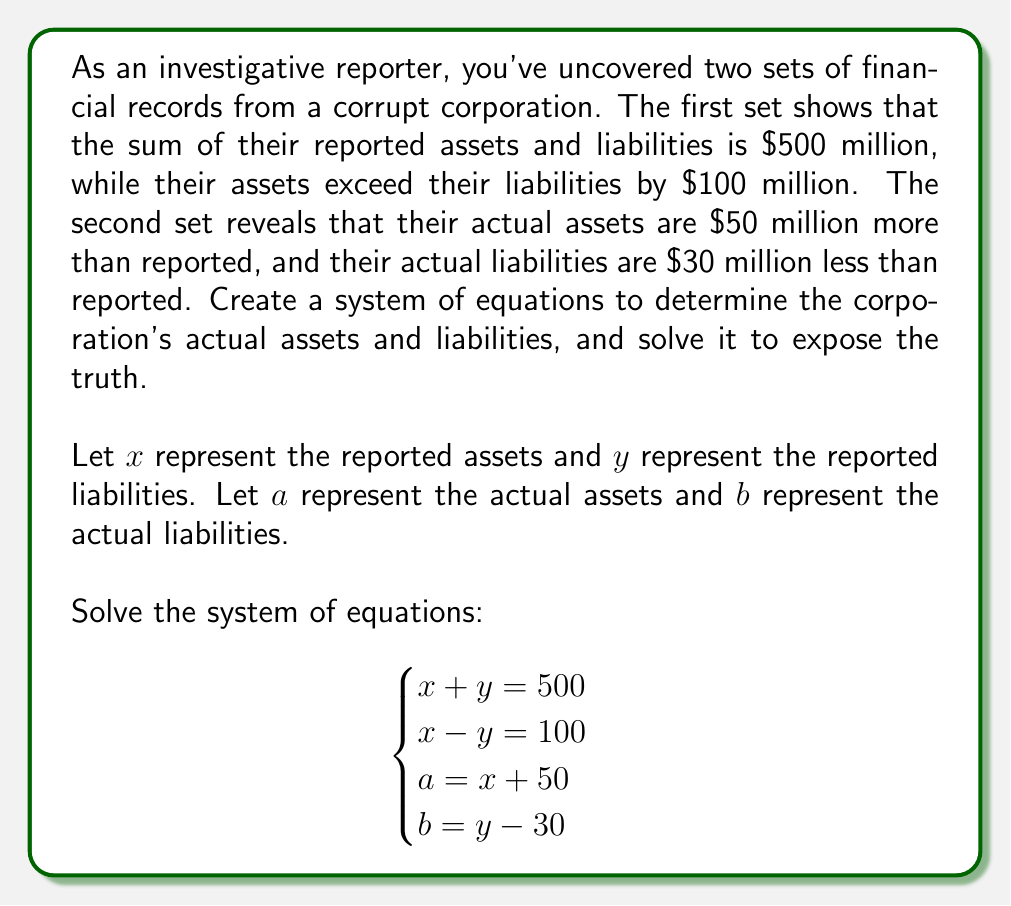Teach me how to tackle this problem. Let's solve this system of equations step by step:

1) From the first two equations, we can solve for $x$ and $y$:
   
   $$x + y = 500 \quad (1)$$
   $$x - y = 100 \quad (2)$$

   Adding (1) and (2):
   $$2x = 600$$
   $$x = 300$$

   Substituting $x = 300$ into (1):
   $$300 + y = 500$$
   $$y = 200$$

2) Now we know the reported assets ($x$) and liabilities ($y$):
   
   Reported assets: $x = 300$ million
   Reported liabilities: $y = 200$ million

3) To find the actual assets ($a$) and liabilities ($b$), we use the last two equations:

   $$a = x + 50 = 300 + 50 = 350$$ million

   $$b = y - 30 = 200 - 30 = 170$$ million

4) Let's verify:
   Actual assets ($350 million) - Actual liabilities ($170 million) = $180 million
   This difference is indeed $80 million more than the reported difference of $100 million.

   Actual assets ($350 million) + Actual liabilities ($170 million) = $520 million
   This sum is indeed $20 million more than the reported sum of $500 million.
Answer: Actual assets: $350 million; Actual liabilities: $170 million 